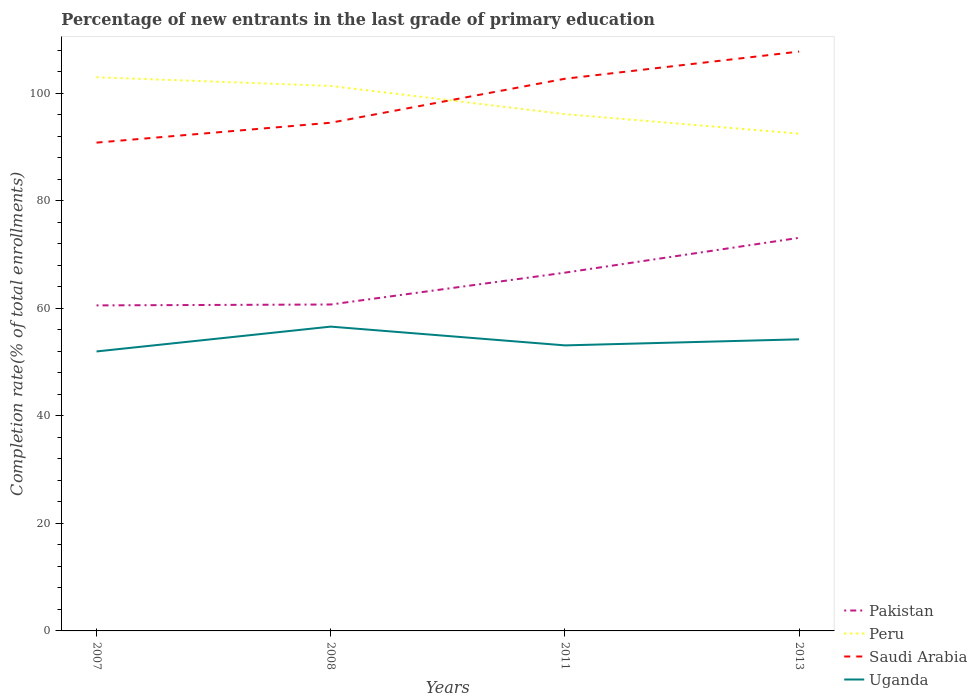Is the number of lines equal to the number of legend labels?
Give a very brief answer. Yes. Across all years, what is the maximum percentage of new entrants in Saudi Arabia?
Ensure brevity in your answer.  90.83. What is the total percentage of new entrants in Saudi Arabia in the graph?
Provide a short and direct response. -13.24. What is the difference between the highest and the second highest percentage of new entrants in Peru?
Ensure brevity in your answer.  10.49. What is the difference between the highest and the lowest percentage of new entrants in Peru?
Ensure brevity in your answer.  2. Is the percentage of new entrants in Pakistan strictly greater than the percentage of new entrants in Peru over the years?
Your response must be concise. Yes. How many years are there in the graph?
Give a very brief answer. 4. What is the difference between two consecutive major ticks on the Y-axis?
Your answer should be compact. 20. Does the graph contain grids?
Give a very brief answer. No. Where does the legend appear in the graph?
Your answer should be compact. Bottom right. How many legend labels are there?
Offer a very short reply. 4. What is the title of the graph?
Your answer should be very brief. Percentage of new entrants in the last grade of primary education. Does "Liberia" appear as one of the legend labels in the graph?
Give a very brief answer. No. What is the label or title of the X-axis?
Provide a succinct answer. Years. What is the label or title of the Y-axis?
Your answer should be compact. Completion rate(% of total enrollments). What is the Completion rate(% of total enrollments) of Pakistan in 2007?
Ensure brevity in your answer.  60.55. What is the Completion rate(% of total enrollments) in Peru in 2007?
Ensure brevity in your answer.  102.99. What is the Completion rate(% of total enrollments) of Saudi Arabia in 2007?
Ensure brevity in your answer.  90.83. What is the Completion rate(% of total enrollments) of Uganda in 2007?
Ensure brevity in your answer.  51.99. What is the Completion rate(% of total enrollments) of Pakistan in 2008?
Your answer should be compact. 60.72. What is the Completion rate(% of total enrollments) in Peru in 2008?
Provide a short and direct response. 101.38. What is the Completion rate(% of total enrollments) of Saudi Arabia in 2008?
Your answer should be compact. 94.53. What is the Completion rate(% of total enrollments) of Uganda in 2008?
Provide a succinct answer. 56.61. What is the Completion rate(% of total enrollments) in Pakistan in 2011?
Offer a terse response. 66.64. What is the Completion rate(% of total enrollments) in Peru in 2011?
Offer a terse response. 96.13. What is the Completion rate(% of total enrollments) of Saudi Arabia in 2011?
Make the answer very short. 102.71. What is the Completion rate(% of total enrollments) in Uganda in 2011?
Offer a terse response. 53.11. What is the Completion rate(% of total enrollments) of Pakistan in 2013?
Provide a short and direct response. 73.12. What is the Completion rate(% of total enrollments) in Peru in 2013?
Make the answer very short. 92.5. What is the Completion rate(% of total enrollments) of Saudi Arabia in 2013?
Make the answer very short. 107.77. What is the Completion rate(% of total enrollments) of Uganda in 2013?
Offer a very short reply. 54.24. Across all years, what is the maximum Completion rate(% of total enrollments) of Pakistan?
Make the answer very short. 73.12. Across all years, what is the maximum Completion rate(% of total enrollments) of Peru?
Offer a terse response. 102.99. Across all years, what is the maximum Completion rate(% of total enrollments) of Saudi Arabia?
Give a very brief answer. 107.77. Across all years, what is the maximum Completion rate(% of total enrollments) of Uganda?
Ensure brevity in your answer.  56.61. Across all years, what is the minimum Completion rate(% of total enrollments) in Pakistan?
Your answer should be compact. 60.55. Across all years, what is the minimum Completion rate(% of total enrollments) in Peru?
Keep it short and to the point. 92.5. Across all years, what is the minimum Completion rate(% of total enrollments) in Saudi Arabia?
Your response must be concise. 90.83. Across all years, what is the minimum Completion rate(% of total enrollments) of Uganda?
Ensure brevity in your answer.  51.99. What is the total Completion rate(% of total enrollments) of Pakistan in the graph?
Keep it short and to the point. 261.04. What is the total Completion rate(% of total enrollments) of Peru in the graph?
Provide a succinct answer. 393.01. What is the total Completion rate(% of total enrollments) of Saudi Arabia in the graph?
Provide a succinct answer. 395.85. What is the total Completion rate(% of total enrollments) of Uganda in the graph?
Keep it short and to the point. 215.95. What is the difference between the Completion rate(% of total enrollments) in Pakistan in 2007 and that in 2008?
Make the answer very short. -0.16. What is the difference between the Completion rate(% of total enrollments) of Peru in 2007 and that in 2008?
Your response must be concise. 1.61. What is the difference between the Completion rate(% of total enrollments) of Saudi Arabia in 2007 and that in 2008?
Your answer should be very brief. -3.7. What is the difference between the Completion rate(% of total enrollments) of Uganda in 2007 and that in 2008?
Provide a succinct answer. -4.62. What is the difference between the Completion rate(% of total enrollments) of Pakistan in 2007 and that in 2011?
Keep it short and to the point. -6.09. What is the difference between the Completion rate(% of total enrollments) in Peru in 2007 and that in 2011?
Offer a very short reply. 6.87. What is the difference between the Completion rate(% of total enrollments) of Saudi Arabia in 2007 and that in 2011?
Offer a terse response. -11.88. What is the difference between the Completion rate(% of total enrollments) of Uganda in 2007 and that in 2011?
Offer a terse response. -1.13. What is the difference between the Completion rate(% of total enrollments) in Pakistan in 2007 and that in 2013?
Keep it short and to the point. -12.57. What is the difference between the Completion rate(% of total enrollments) in Peru in 2007 and that in 2013?
Give a very brief answer. 10.49. What is the difference between the Completion rate(% of total enrollments) of Saudi Arabia in 2007 and that in 2013?
Provide a short and direct response. -16.94. What is the difference between the Completion rate(% of total enrollments) in Uganda in 2007 and that in 2013?
Offer a terse response. -2.26. What is the difference between the Completion rate(% of total enrollments) of Pakistan in 2008 and that in 2011?
Make the answer very short. -5.92. What is the difference between the Completion rate(% of total enrollments) of Peru in 2008 and that in 2011?
Your answer should be very brief. 5.26. What is the difference between the Completion rate(% of total enrollments) of Saudi Arabia in 2008 and that in 2011?
Provide a succinct answer. -8.18. What is the difference between the Completion rate(% of total enrollments) in Uganda in 2008 and that in 2011?
Your answer should be compact. 3.49. What is the difference between the Completion rate(% of total enrollments) in Pakistan in 2008 and that in 2013?
Offer a very short reply. -12.4. What is the difference between the Completion rate(% of total enrollments) in Peru in 2008 and that in 2013?
Give a very brief answer. 8.88. What is the difference between the Completion rate(% of total enrollments) of Saudi Arabia in 2008 and that in 2013?
Make the answer very short. -13.24. What is the difference between the Completion rate(% of total enrollments) of Uganda in 2008 and that in 2013?
Ensure brevity in your answer.  2.36. What is the difference between the Completion rate(% of total enrollments) of Pakistan in 2011 and that in 2013?
Give a very brief answer. -6.48. What is the difference between the Completion rate(% of total enrollments) in Peru in 2011 and that in 2013?
Your answer should be very brief. 3.62. What is the difference between the Completion rate(% of total enrollments) of Saudi Arabia in 2011 and that in 2013?
Make the answer very short. -5.06. What is the difference between the Completion rate(% of total enrollments) in Uganda in 2011 and that in 2013?
Offer a terse response. -1.13. What is the difference between the Completion rate(% of total enrollments) in Pakistan in 2007 and the Completion rate(% of total enrollments) in Peru in 2008?
Your answer should be compact. -40.83. What is the difference between the Completion rate(% of total enrollments) in Pakistan in 2007 and the Completion rate(% of total enrollments) in Saudi Arabia in 2008?
Offer a very short reply. -33.98. What is the difference between the Completion rate(% of total enrollments) of Pakistan in 2007 and the Completion rate(% of total enrollments) of Uganda in 2008?
Provide a short and direct response. 3.95. What is the difference between the Completion rate(% of total enrollments) of Peru in 2007 and the Completion rate(% of total enrollments) of Saudi Arabia in 2008?
Your response must be concise. 8.46. What is the difference between the Completion rate(% of total enrollments) of Peru in 2007 and the Completion rate(% of total enrollments) of Uganda in 2008?
Your answer should be very brief. 46.39. What is the difference between the Completion rate(% of total enrollments) in Saudi Arabia in 2007 and the Completion rate(% of total enrollments) in Uganda in 2008?
Offer a very short reply. 34.23. What is the difference between the Completion rate(% of total enrollments) in Pakistan in 2007 and the Completion rate(% of total enrollments) in Peru in 2011?
Provide a succinct answer. -35.57. What is the difference between the Completion rate(% of total enrollments) of Pakistan in 2007 and the Completion rate(% of total enrollments) of Saudi Arabia in 2011?
Provide a succinct answer. -42.16. What is the difference between the Completion rate(% of total enrollments) of Pakistan in 2007 and the Completion rate(% of total enrollments) of Uganda in 2011?
Ensure brevity in your answer.  7.44. What is the difference between the Completion rate(% of total enrollments) of Peru in 2007 and the Completion rate(% of total enrollments) of Saudi Arabia in 2011?
Offer a terse response. 0.28. What is the difference between the Completion rate(% of total enrollments) of Peru in 2007 and the Completion rate(% of total enrollments) of Uganda in 2011?
Make the answer very short. 49.88. What is the difference between the Completion rate(% of total enrollments) in Saudi Arabia in 2007 and the Completion rate(% of total enrollments) in Uganda in 2011?
Ensure brevity in your answer.  37.72. What is the difference between the Completion rate(% of total enrollments) of Pakistan in 2007 and the Completion rate(% of total enrollments) of Peru in 2013?
Offer a very short reply. -31.95. What is the difference between the Completion rate(% of total enrollments) in Pakistan in 2007 and the Completion rate(% of total enrollments) in Saudi Arabia in 2013?
Ensure brevity in your answer.  -47.22. What is the difference between the Completion rate(% of total enrollments) in Pakistan in 2007 and the Completion rate(% of total enrollments) in Uganda in 2013?
Ensure brevity in your answer.  6.31. What is the difference between the Completion rate(% of total enrollments) of Peru in 2007 and the Completion rate(% of total enrollments) of Saudi Arabia in 2013?
Your answer should be compact. -4.78. What is the difference between the Completion rate(% of total enrollments) of Peru in 2007 and the Completion rate(% of total enrollments) of Uganda in 2013?
Offer a terse response. 48.75. What is the difference between the Completion rate(% of total enrollments) in Saudi Arabia in 2007 and the Completion rate(% of total enrollments) in Uganda in 2013?
Your response must be concise. 36.59. What is the difference between the Completion rate(% of total enrollments) of Pakistan in 2008 and the Completion rate(% of total enrollments) of Peru in 2011?
Your answer should be very brief. -35.41. What is the difference between the Completion rate(% of total enrollments) in Pakistan in 2008 and the Completion rate(% of total enrollments) in Saudi Arabia in 2011?
Your response must be concise. -41.99. What is the difference between the Completion rate(% of total enrollments) of Pakistan in 2008 and the Completion rate(% of total enrollments) of Uganda in 2011?
Keep it short and to the point. 7.6. What is the difference between the Completion rate(% of total enrollments) in Peru in 2008 and the Completion rate(% of total enrollments) in Saudi Arabia in 2011?
Provide a short and direct response. -1.33. What is the difference between the Completion rate(% of total enrollments) in Peru in 2008 and the Completion rate(% of total enrollments) in Uganda in 2011?
Your answer should be very brief. 48.27. What is the difference between the Completion rate(% of total enrollments) of Saudi Arabia in 2008 and the Completion rate(% of total enrollments) of Uganda in 2011?
Ensure brevity in your answer.  41.42. What is the difference between the Completion rate(% of total enrollments) in Pakistan in 2008 and the Completion rate(% of total enrollments) in Peru in 2013?
Provide a succinct answer. -31.78. What is the difference between the Completion rate(% of total enrollments) of Pakistan in 2008 and the Completion rate(% of total enrollments) of Saudi Arabia in 2013?
Give a very brief answer. -47.05. What is the difference between the Completion rate(% of total enrollments) of Pakistan in 2008 and the Completion rate(% of total enrollments) of Uganda in 2013?
Ensure brevity in your answer.  6.48. What is the difference between the Completion rate(% of total enrollments) of Peru in 2008 and the Completion rate(% of total enrollments) of Saudi Arabia in 2013?
Your response must be concise. -6.39. What is the difference between the Completion rate(% of total enrollments) in Peru in 2008 and the Completion rate(% of total enrollments) in Uganda in 2013?
Your response must be concise. 47.14. What is the difference between the Completion rate(% of total enrollments) of Saudi Arabia in 2008 and the Completion rate(% of total enrollments) of Uganda in 2013?
Provide a succinct answer. 40.29. What is the difference between the Completion rate(% of total enrollments) in Pakistan in 2011 and the Completion rate(% of total enrollments) in Peru in 2013?
Offer a terse response. -25.86. What is the difference between the Completion rate(% of total enrollments) in Pakistan in 2011 and the Completion rate(% of total enrollments) in Saudi Arabia in 2013?
Ensure brevity in your answer.  -41.13. What is the difference between the Completion rate(% of total enrollments) in Pakistan in 2011 and the Completion rate(% of total enrollments) in Uganda in 2013?
Keep it short and to the point. 12.4. What is the difference between the Completion rate(% of total enrollments) in Peru in 2011 and the Completion rate(% of total enrollments) in Saudi Arabia in 2013?
Give a very brief answer. -11.64. What is the difference between the Completion rate(% of total enrollments) of Peru in 2011 and the Completion rate(% of total enrollments) of Uganda in 2013?
Give a very brief answer. 41.88. What is the difference between the Completion rate(% of total enrollments) in Saudi Arabia in 2011 and the Completion rate(% of total enrollments) in Uganda in 2013?
Offer a terse response. 48.47. What is the average Completion rate(% of total enrollments) in Pakistan per year?
Provide a short and direct response. 65.26. What is the average Completion rate(% of total enrollments) of Peru per year?
Offer a terse response. 98.25. What is the average Completion rate(% of total enrollments) of Saudi Arabia per year?
Offer a terse response. 98.96. What is the average Completion rate(% of total enrollments) of Uganda per year?
Ensure brevity in your answer.  53.99. In the year 2007, what is the difference between the Completion rate(% of total enrollments) of Pakistan and Completion rate(% of total enrollments) of Peru?
Offer a terse response. -42.44. In the year 2007, what is the difference between the Completion rate(% of total enrollments) in Pakistan and Completion rate(% of total enrollments) in Saudi Arabia?
Offer a terse response. -30.28. In the year 2007, what is the difference between the Completion rate(% of total enrollments) of Pakistan and Completion rate(% of total enrollments) of Uganda?
Your answer should be compact. 8.57. In the year 2007, what is the difference between the Completion rate(% of total enrollments) of Peru and Completion rate(% of total enrollments) of Saudi Arabia?
Ensure brevity in your answer.  12.16. In the year 2007, what is the difference between the Completion rate(% of total enrollments) of Peru and Completion rate(% of total enrollments) of Uganda?
Your response must be concise. 51.01. In the year 2007, what is the difference between the Completion rate(% of total enrollments) of Saudi Arabia and Completion rate(% of total enrollments) of Uganda?
Your response must be concise. 38.85. In the year 2008, what is the difference between the Completion rate(% of total enrollments) in Pakistan and Completion rate(% of total enrollments) in Peru?
Keep it short and to the point. -40.66. In the year 2008, what is the difference between the Completion rate(% of total enrollments) of Pakistan and Completion rate(% of total enrollments) of Saudi Arabia?
Your answer should be compact. -33.81. In the year 2008, what is the difference between the Completion rate(% of total enrollments) in Pakistan and Completion rate(% of total enrollments) in Uganda?
Give a very brief answer. 4.11. In the year 2008, what is the difference between the Completion rate(% of total enrollments) of Peru and Completion rate(% of total enrollments) of Saudi Arabia?
Ensure brevity in your answer.  6.85. In the year 2008, what is the difference between the Completion rate(% of total enrollments) of Peru and Completion rate(% of total enrollments) of Uganda?
Your response must be concise. 44.78. In the year 2008, what is the difference between the Completion rate(% of total enrollments) of Saudi Arabia and Completion rate(% of total enrollments) of Uganda?
Offer a terse response. 37.93. In the year 2011, what is the difference between the Completion rate(% of total enrollments) in Pakistan and Completion rate(% of total enrollments) in Peru?
Keep it short and to the point. -29.48. In the year 2011, what is the difference between the Completion rate(% of total enrollments) in Pakistan and Completion rate(% of total enrollments) in Saudi Arabia?
Give a very brief answer. -36.07. In the year 2011, what is the difference between the Completion rate(% of total enrollments) of Pakistan and Completion rate(% of total enrollments) of Uganda?
Offer a very short reply. 13.53. In the year 2011, what is the difference between the Completion rate(% of total enrollments) of Peru and Completion rate(% of total enrollments) of Saudi Arabia?
Make the answer very short. -6.59. In the year 2011, what is the difference between the Completion rate(% of total enrollments) of Peru and Completion rate(% of total enrollments) of Uganda?
Ensure brevity in your answer.  43.01. In the year 2011, what is the difference between the Completion rate(% of total enrollments) of Saudi Arabia and Completion rate(% of total enrollments) of Uganda?
Provide a short and direct response. 49.6. In the year 2013, what is the difference between the Completion rate(% of total enrollments) in Pakistan and Completion rate(% of total enrollments) in Peru?
Your response must be concise. -19.38. In the year 2013, what is the difference between the Completion rate(% of total enrollments) of Pakistan and Completion rate(% of total enrollments) of Saudi Arabia?
Provide a short and direct response. -34.65. In the year 2013, what is the difference between the Completion rate(% of total enrollments) in Pakistan and Completion rate(% of total enrollments) in Uganda?
Provide a succinct answer. 18.88. In the year 2013, what is the difference between the Completion rate(% of total enrollments) of Peru and Completion rate(% of total enrollments) of Saudi Arabia?
Offer a very short reply. -15.27. In the year 2013, what is the difference between the Completion rate(% of total enrollments) in Peru and Completion rate(% of total enrollments) in Uganda?
Provide a succinct answer. 38.26. In the year 2013, what is the difference between the Completion rate(% of total enrollments) in Saudi Arabia and Completion rate(% of total enrollments) in Uganda?
Your answer should be very brief. 53.53. What is the ratio of the Completion rate(% of total enrollments) of Pakistan in 2007 to that in 2008?
Provide a short and direct response. 1. What is the ratio of the Completion rate(% of total enrollments) of Peru in 2007 to that in 2008?
Give a very brief answer. 1.02. What is the ratio of the Completion rate(% of total enrollments) in Saudi Arabia in 2007 to that in 2008?
Keep it short and to the point. 0.96. What is the ratio of the Completion rate(% of total enrollments) in Uganda in 2007 to that in 2008?
Provide a succinct answer. 0.92. What is the ratio of the Completion rate(% of total enrollments) in Pakistan in 2007 to that in 2011?
Give a very brief answer. 0.91. What is the ratio of the Completion rate(% of total enrollments) in Peru in 2007 to that in 2011?
Offer a terse response. 1.07. What is the ratio of the Completion rate(% of total enrollments) in Saudi Arabia in 2007 to that in 2011?
Make the answer very short. 0.88. What is the ratio of the Completion rate(% of total enrollments) in Uganda in 2007 to that in 2011?
Provide a short and direct response. 0.98. What is the ratio of the Completion rate(% of total enrollments) of Pakistan in 2007 to that in 2013?
Make the answer very short. 0.83. What is the ratio of the Completion rate(% of total enrollments) of Peru in 2007 to that in 2013?
Keep it short and to the point. 1.11. What is the ratio of the Completion rate(% of total enrollments) of Saudi Arabia in 2007 to that in 2013?
Give a very brief answer. 0.84. What is the ratio of the Completion rate(% of total enrollments) of Uganda in 2007 to that in 2013?
Your answer should be very brief. 0.96. What is the ratio of the Completion rate(% of total enrollments) of Pakistan in 2008 to that in 2011?
Provide a succinct answer. 0.91. What is the ratio of the Completion rate(% of total enrollments) of Peru in 2008 to that in 2011?
Offer a very short reply. 1.05. What is the ratio of the Completion rate(% of total enrollments) of Saudi Arabia in 2008 to that in 2011?
Your response must be concise. 0.92. What is the ratio of the Completion rate(% of total enrollments) in Uganda in 2008 to that in 2011?
Keep it short and to the point. 1.07. What is the ratio of the Completion rate(% of total enrollments) of Pakistan in 2008 to that in 2013?
Ensure brevity in your answer.  0.83. What is the ratio of the Completion rate(% of total enrollments) in Peru in 2008 to that in 2013?
Provide a short and direct response. 1.1. What is the ratio of the Completion rate(% of total enrollments) in Saudi Arabia in 2008 to that in 2013?
Make the answer very short. 0.88. What is the ratio of the Completion rate(% of total enrollments) in Uganda in 2008 to that in 2013?
Your answer should be very brief. 1.04. What is the ratio of the Completion rate(% of total enrollments) in Pakistan in 2011 to that in 2013?
Your answer should be very brief. 0.91. What is the ratio of the Completion rate(% of total enrollments) in Peru in 2011 to that in 2013?
Provide a succinct answer. 1.04. What is the ratio of the Completion rate(% of total enrollments) in Saudi Arabia in 2011 to that in 2013?
Give a very brief answer. 0.95. What is the ratio of the Completion rate(% of total enrollments) in Uganda in 2011 to that in 2013?
Provide a short and direct response. 0.98. What is the difference between the highest and the second highest Completion rate(% of total enrollments) of Pakistan?
Offer a terse response. 6.48. What is the difference between the highest and the second highest Completion rate(% of total enrollments) in Peru?
Offer a terse response. 1.61. What is the difference between the highest and the second highest Completion rate(% of total enrollments) of Saudi Arabia?
Offer a terse response. 5.06. What is the difference between the highest and the second highest Completion rate(% of total enrollments) in Uganda?
Provide a succinct answer. 2.36. What is the difference between the highest and the lowest Completion rate(% of total enrollments) in Pakistan?
Your answer should be very brief. 12.57. What is the difference between the highest and the lowest Completion rate(% of total enrollments) in Peru?
Offer a very short reply. 10.49. What is the difference between the highest and the lowest Completion rate(% of total enrollments) in Saudi Arabia?
Provide a succinct answer. 16.94. What is the difference between the highest and the lowest Completion rate(% of total enrollments) in Uganda?
Keep it short and to the point. 4.62. 